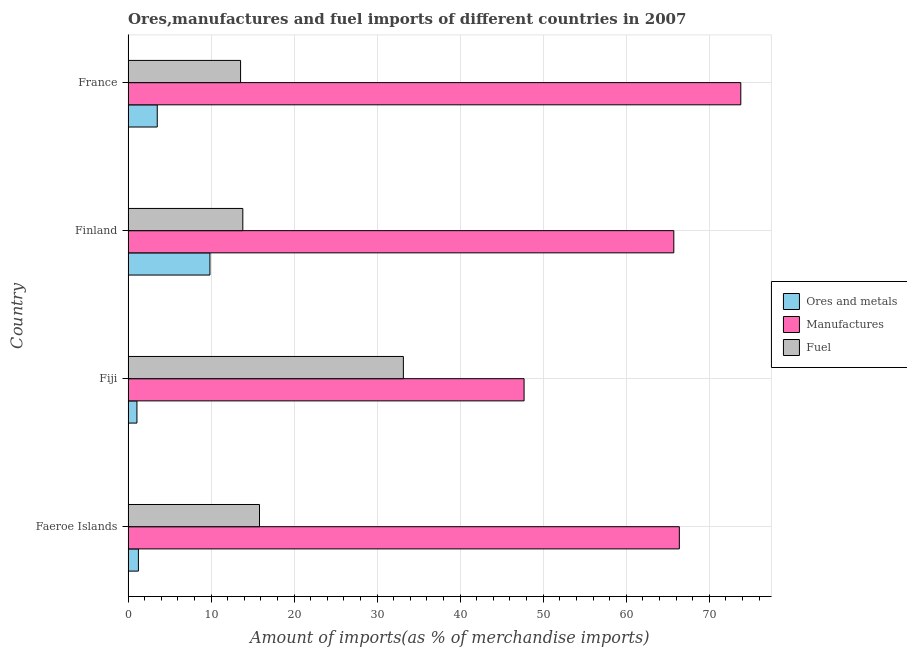How many groups of bars are there?
Your answer should be compact. 4. How many bars are there on the 2nd tick from the top?
Offer a very short reply. 3. What is the label of the 3rd group of bars from the top?
Ensure brevity in your answer.  Fiji. What is the percentage of fuel imports in Faeroe Islands?
Offer a terse response. 15.83. Across all countries, what is the maximum percentage of manufactures imports?
Offer a very short reply. 73.8. Across all countries, what is the minimum percentage of fuel imports?
Your answer should be compact. 13.55. In which country was the percentage of fuel imports maximum?
Ensure brevity in your answer.  Fiji. In which country was the percentage of manufactures imports minimum?
Ensure brevity in your answer.  Fiji. What is the total percentage of fuel imports in the graph?
Keep it short and to the point. 76.36. What is the difference between the percentage of manufactures imports in Fiji and the percentage of fuel imports in France?
Your response must be concise. 34.15. What is the average percentage of manufactures imports per country?
Keep it short and to the point. 63.41. What is the difference between the percentage of ores and metals imports and percentage of fuel imports in France?
Ensure brevity in your answer.  -10.04. What is the ratio of the percentage of fuel imports in Fiji to that in Finland?
Your response must be concise. 2.4. What is the difference between the highest and the second highest percentage of manufactures imports?
Offer a very short reply. 7.4. What is the difference between the highest and the lowest percentage of ores and metals imports?
Make the answer very short. 8.79. Is the sum of the percentage of ores and metals imports in Finland and France greater than the maximum percentage of fuel imports across all countries?
Offer a terse response. No. What does the 3rd bar from the top in Finland represents?
Your answer should be compact. Ores and metals. What does the 2nd bar from the bottom in Faeroe Islands represents?
Provide a short and direct response. Manufactures. Does the graph contain grids?
Offer a very short reply. Yes. Where does the legend appear in the graph?
Provide a short and direct response. Center right. How many legend labels are there?
Make the answer very short. 3. What is the title of the graph?
Make the answer very short. Ores,manufactures and fuel imports of different countries in 2007. Does "Coal sources" appear as one of the legend labels in the graph?
Ensure brevity in your answer.  No. What is the label or title of the X-axis?
Offer a very short reply. Amount of imports(as % of merchandise imports). What is the Amount of imports(as % of merchandise imports) of Ores and metals in Faeroe Islands?
Provide a short and direct response. 1.24. What is the Amount of imports(as % of merchandise imports) in Manufactures in Faeroe Islands?
Your answer should be compact. 66.4. What is the Amount of imports(as % of merchandise imports) in Fuel in Faeroe Islands?
Provide a short and direct response. 15.83. What is the Amount of imports(as % of merchandise imports) in Ores and metals in Fiji?
Give a very brief answer. 1.07. What is the Amount of imports(as % of merchandise imports) of Manufactures in Fiji?
Offer a very short reply. 47.7. What is the Amount of imports(as % of merchandise imports) of Fuel in Fiji?
Ensure brevity in your answer.  33.16. What is the Amount of imports(as % of merchandise imports) of Ores and metals in Finland?
Provide a succinct answer. 9.86. What is the Amount of imports(as % of merchandise imports) of Manufactures in Finland?
Your answer should be compact. 65.73. What is the Amount of imports(as % of merchandise imports) of Fuel in Finland?
Keep it short and to the point. 13.82. What is the Amount of imports(as % of merchandise imports) in Ores and metals in France?
Your answer should be very brief. 3.51. What is the Amount of imports(as % of merchandise imports) in Manufactures in France?
Offer a very short reply. 73.8. What is the Amount of imports(as % of merchandise imports) in Fuel in France?
Keep it short and to the point. 13.55. Across all countries, what is the maximum Amount of imports(as % of merchandise imports) of Ores and metals?
Your answer should be very brief. 9.86. Across all countries, what is the maximum Amount of imports(as % of merchandise imports) in Manufactures?
Provide a short and direct response. 73.8. Across all countries, what is the maximum Amount of imports(as % of merchandise imports) in Fuel?
Offer a very short reply. 33.16. Across all countries, what is the minimum Amount of imports(as % of merchandise imports) of Ores and metals?
Give a very brief answer. 1.07. Across all countries, what is the minimum Amount of imports(as % of merchandise imports) of Manufactures?
Keep it short and to the point. 47.7. Across all countries, what is the minimum Amount of imports(as % of merchandise imports) of Fuel?
Your response must be concise. 13.55. What is the total Amount of imports(as % of merchandise imports) of Ores and metals in the graph?
Give a very brief answer. 15.69. What is the total Amount of imports(as % of merchandise imports) in Manufactures in the graph?
Offer a terse response. 253.63. What is the total Amount of imports(as % of merchandise imports) in Fuel in the graph?
Your answer should be very brief. 76.36. What is the difference between the Amount of imports(as % of merchandise imports) of Ores and metals in Faeroe Islands and that in Fiji?
Your answer should be very brief. 0.18. What is the difference between the Amount of imports(as % of merchandise imports) in Manufactures in Faeroe Islands and that in Fiji?
Provide a short and direct response. 18.7. What is the difference between the Amount of imports(as % of merchandise imports) of Fuel in Faeroe Islands and that in Fiji?
Your response must be concise. -17.33. What is the difference between the Amount of imports(as % of merchandise imports) of Ores and metals in Faeroe Islands and that in Finland?
Provide a succinct answer. -8.62. What is the difference between the Amount of imports(as % of merchandise imports) of Manufactures in Faeroe Islands and that in Finland?
Ensure brevity in your answer.  0.67. What is the difference between the Amount of imports(as % of merchandise imports) of Fuel in Faeroe Islands and that in Finland?
Ensure brevity in your answer.  2.01. What is the difference between the Amount of imports(as % of merchandise imports) of Ores and metals in Faeroe Islands and that in France?
Give a very brief answer. -2.27. What is the difference between the Amount of imports(as % of merchandise imports) of Manufactures in Faeroe Islands and that in France?
Your answer should be compact. -7.4. What is the difference between the Amount of imports(as % of merchandise imports) in Fuel in Faeroe Islands and that in France?
Your answer should be compact. 2.28. What is the difference between the Amount of imports(as % of merchandise imports) of Ores and metals in Fiji and that in Finland?
Offer a very short reply. -8.79. What is the difference between the Amount of imports(as % of merchandise imports) in Manufactures in Fiji and that in Finland?
Give a very brief answer. -18.04. What is the difference between the Amount of imports(as % of merchandise imports) of Fuel in Fiji and that in Finland?
Provide a succinct answer. 19.34. What is the difference between the Amount of imports(as % of merchandise imports) in Ores and metals in Fiji and that in France?
Give a very brief answer. -2.45. What is the difference between the Amount of imports(as % of merchandise imports) in Manufactures in Fiji and that in France?
Ensure brevity in your answer.  -26.1. What is the difference between the Amount of imports(as % of merchandise imports) in Fuel in Fiji and that in France?
Ensure brevity in your answer.  19.61. What is the difference between the Amount of imports(as % of merchandise imports) of Ores and metals in Finland and that in France?
Give a very brief answer. 6.35. What is the difference between the Amount of imports(as % of merchandise imports) in Manufactures in Finland and that in France?
Offer a terse response. -8.07. What is the difference between the Amount of imports(as % of merchandise imports) of Fuel in Finland and that in France?
Ensure brevity in your answer.  0.27. What is the difference between the Amount of imports(as % of merchandise imports) in Ores and metals in Faeroe Islands and the Amount of imports(as % of merchandise imports) in Manufactures in Fiji?
Your answer should be compact. -46.45. What is the difference between the Amount of imports(as % of merchandise imports) in Ores and metals in Faeroe Islands and the Amount of imports(as % of merchandise imports) in Fuel in Fiji?
Offer a very short reply. -31.91. What is the difference between the Amount of imports(as % of merchandise imports) of Manufactures in Faeroe Islands and the Amount of imports(as % of merchandise imports) of Fuel in Fiji?
Keep it short and to the point. 33.24. What is the difference between the Amount of imports(as % of merchandise imports) of Ores and metals in Faeroe Islands and the Amount of imports(as % of merchandise imports) of Manufactures in Finland?
Give a very brief answer. -64.49. What is the difference between the Amount of imports(as % of merchandise imports) in Ores and metals in Faeroe Islands and the Amount of imports(as % of merchandise imports) in Fuel in Finland?
Your response must be concise. -12.57. What is the difference between the Amount of imports(as % of merchandise imports) in Manufactures in Faeroe Islands and the Amount of imports(as % of merchandise imports) in Fuel in Finland?
Your answer should be very brief. 52.58. What is the difference between the Amount of imports(as % of merchandise imports) of Ores and metals in Faeroe Islands and the Amount of imports(as % of merchandise imports) of Manufactures in France?
Offer a very short reply. -72.56. What is the difference between the Amount of imports(as % of merchandise imports) in Ores and metals in Faeroe Islands and the Amount of imports(as % of merchandise imports) in Fuel in France?
Offer a terse response. -12.31. What is the difference between the Amount of imports(as % of merchandise imports) in Manufactures in Faeroe Islands and the Amount of imports(as % of merchandise imports) in Fuel in France?
Provide a short and direct response. 52.85. What is the difference between the Amount of imports(as % of merchandise imports) of Ores and metals in Fiji and the Amount of imports(as % of merchandise imports) of Manufactures in Finland?
Provide a succinct answer. -64.67. What is the difference between the Amount of imports(as % of merchandise imports) in Ores and metals in Fiji and the Amount of imports(as % of merchandise imports) in Fuel in Finland?
Your answer should be very brief. -12.75. What is the difference between the Amount of imports(as % of merchandise imports) in Manufactures in Fiji and the Amount of imports(as % of merchandise imports) in Fuel in Finland?
Ensure brevity in your answer.  33.88. What is the difference between the Amount of imports(as % of merchandise imports) in Ores and metals in Fiji and the Amount of imports(as % of merchandise imports) in Manufactures in France?
Your answer should be compact. -72.73. What is the difference between the Amount of imports(as % of merchandise imports) in Ores and metals in Fiji and the Amount of imports(as % of merchandise imports) in Fuel in France?
Offer a very short reply. -12.48. What is the difference between the Amount of imports(as % of merchandise imports) of Manufactures in Fiji and the Amount of imports(as % of merchandise imports) of Fuel in France?
Your answer should be compact. 34.15. What is the difference between the Amount of imports(as % of merchandise imports) in Ores and metals in Finland and the Amount of imports(as % of merchandise imports) in Manufactures in France?
Make the answer very short. -63.94. What is the difference between the Amount of imports(as % of merchandise imports) in Ores and metals in Finland and the Amount of imports(as % of merchandise imports) in Fuel in France?
Keep it short and to the point. -3.69. What is the difference between the Amount of imports(as % of merchandise imports) of Manufactures in Finland and the Amount of imports(as % of merchandise imports) of Fuel in France?
Give a very brief answer. 52.18. What is the average Amount of imports(as % of merchandise imports) in Ores and metals per country?
Keep it short and to the point. 3.92. What is the average Amount of imports(as % of merchandise imports) in Manufactures per country?
Offer a terse response. 63.41. What is the average Amount of imports(as % of merchandise imports) of Fuel per country?
Offer a terse response. 19.09. What is the difference between the Amount of imports(as % of merchandise imports) in Ores and metals and Amount of imports(as % of merchandise imports) in Manufactures in Faeroe Islands?
Ensure brevity in your answer.  -65.15. What is the difference between the Amount of imports(as % of merchandise imports) of Ores and metals and Amount of imports(as % of merchandise imports) of Fuel in Faeroe Islands?
Ensure brevity in your answer.  -14.59. What is the difference between the Amount of imports(as % of merchandise imports) of Manufactures and Amount of imports(as % of merchandise imports) of Fuel in Faeroe Islands?
Provide a short and direct response. 50.57. What is the difference between the Amount of imports(as % of merchandise imports) of Ores and metals and Amount of imports(as % of merchandise imports) of Manufactures in Fiji?
Ensure brevity in your answer.  -46.63. What is the difference between the Amount of imports(as % of merchandise imports) in Ores and metals and Amount of imports(as % of merchandise imports) in Fuel in Fiji?
Keep it short and to the point. -32.09. What is the difference between the Amount of imports(as % of merchandise imports) of Manufactures and Amount of imports(as % of merchandise imports) of Fuel in Fiji?
Provide a short and direct response. 14.54. What is the difference between the Amount of imports(as % of merchandise imports) of Ores and metals and Amount of imports(as % of merchandise imports) of Manufactures in Finland?
Provide a short and direct response. -55.87. What is the difference between the Amount of imports(as % of merchandise imports) in Ores and metals and Amount of imports(as % of merchandise imports) in Fuel in Finland?
Ensure brevity in your answer.  -3.96. What is the difference between the Amount of imports(as % of merchandise imports) in Manufactures and Amount of imports(as % of merchandise imports) in Fuel in Finland?
Your answer should be compact. 51.91. What is the difference between the Amount of imports(as % of merchandise imports) of Ores and metals and Amount of imports(as % of merchandise imports) of Manufactures in France?
Your answer should be compact. -70.29. What is the difference between the Amount of imports(as % of merchandise imports) of Ores and metals and Amount of imports(as % of merchandise imports) of Fuel in France?
Give a very brief answer. -10.04. What is the difference between the Amount of imports(as % of merchandise imports) in Manufactures and Amount of imports(as % of merchandise imports) in Fuel in France?
Provide a short and direct response. 60.25. What is the ratio of the Amount of imports(as % of merchandise imports) of Ores and metals in Faeroe Islands to that in Fiji?
Keep it short and to the point. 1.17. What is the ratio of the Amount of imports(as % of merchandise imports) of Manufactures in Faeroe Islands to that in Fiji?
Make the answer very short. 1.39. What is the ratio of the Amount of imports(as % of merchandise imports) of Fuel in Faeroe Islands to that in Fiji?
Offer a terse response. 0.48. What is the ratio of the Amount of imports(as % of merchandise imports) of Ores and metals in Faeroe Islands to that in Finland?
Give a very brief answer. 0.13. What is the ratio of the Amount of imports(as % of merchandise imports) in Manufactures in Faeroe Islands to that in Finland?
Your response must be concise. 1.01. What is the ratio of the Amount of imports(as % of merchandise imports) in Fuel in Faeroe Islands to that in Finland?
Your answer should be very brief. 1.15. What is the ratio of the Amount of imports(as % of merchandise imports) of Ores and metals in Faeroe Islands to that in France?
Provide a succinct answer. 0.35. What is the ratio of the Amount of imports(as % of merchandise imports) in Manufactures in Faeroe Islands to that in France?
Your answer should be compact. 0.9. What is the ratio of the Amount of imports(as % of merchandise imports) in Fuel in Faeroe Islands to that in France?
Offer a terse response. 1.17. What is the ratio of the Amount of imports(as % of merchandise imports) of Ores and metals in Fiji to that in Finland?
Make the answer very short. 0.11. What is the ratio of the Amount of imports(as % of merchandise imports) in Manufactures in Fiji to that in Finland?
Ensure brevity in your answer.  0.73. What is the ratio of the Amount of imports(as % of merchandise imports) of Fuel in Fiji to that in Finland?
Give a very brief answer. 2.4. What is the ratio of the Amount of imports(as % of merchandise imports) in Ores and metals in Fiji to that in France?
Ensure brevity in your answer.  0.3. What is the ratio of the Amount of imports(as % of merchandise imports) of Manufactures in Fiji to that in France?
Offer a very short reply. 0.65. What is the ratio of the Amount of imports(as % of merchandise imports) in Fuel in Fiji to that in France?
Keep it short and to the point. 2.45. What is the ratio of the Amount of imports(as % of merchandise imports) of Ores and metals in Finland to that in France?
Keep it short and to the point. 2.81. What is the ratio of the Amount of imports(as % of merchandise imports) of Manufactures in Finland to that in France?
Give a very brief answer. 0.89. What is the ratio of the Amount of imports(as % of merchandise imports) of Fuel in Finland to that in France?
Offer a terse response. 1.02. What is the difference between the highest and the second highest Amount of imports(as % of merchandise imports) of Ores and metals?
Your answer should be compact. 6.35. What is the difference between the highest and the second highest Amount of imports(as % of merchandise imports) of Manufactures?
Offer a terse response. 7.4. What is the difference between the highest and the second highest Amount of imports(as % of merchandise imports) in Fuel?
Your answer should be very brief. 17.33. What is the difference between the highest and the lowest Amount of imports(as % of merchandise imports) in Ores and metals?
Offer a very short reply. 8.79. What is the difference between the highest and the lowest Amount of imports(as % of merchandise imports) of Manufactures?
Your answer should be very brief. 26.1. What is the difference between the highest and the lowest Amount of imports(as % of merchandise imports) in Fuel?
Your response must be concise. 19.61. 